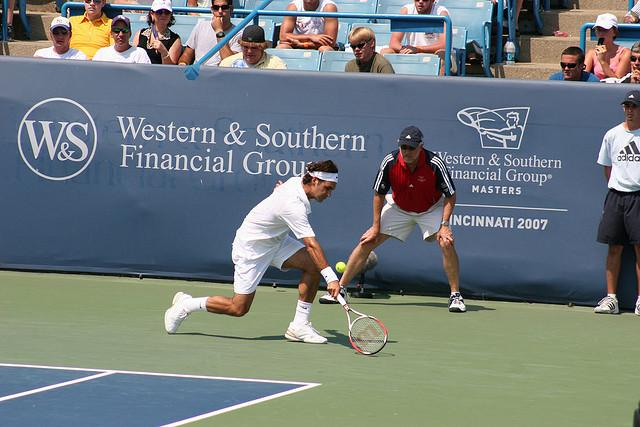When was the advertised company founded? 2007 